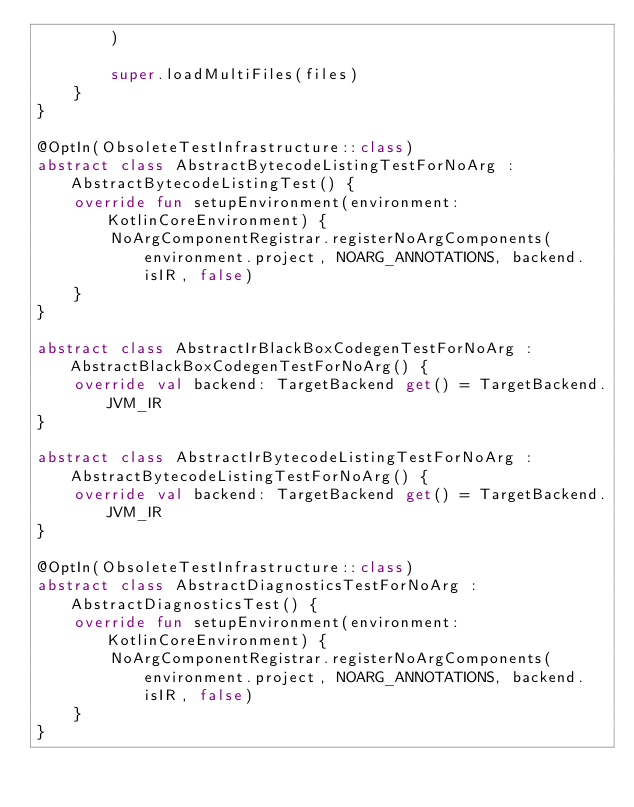<code> <loc_0><loc_0><loc_500><loc_500><_Kotlin_>        )

        super.loadMultiFiles(files)
    }
}

@OptIn(ObsoleteTestInfrastructure::class)
abstract class AbstractBytecodeListingTestForNoArg : AbstractBytecodeListingTest() {
    override fun setupEnvironment(environment: KotlinCoreEnvironment) {
        NoArgComponentRegistrar.registerNoArgComponents(environment.project, NOARG_ANNOTATIONS, backend.isIR, false)
    }
}

abstract class AbstractIrBlackBoxCodegenTestForNoArg : AbstractBlackBoxCodegenTestForNoArg() {
    override val backend: TargetBackend get() = TargetBackend.JVM_IR
}

abstract class AbstractIrBytecodeListingTestForNoArg : AbstractBytecodeListingTestForNoArg() {
    override val backend: TargetBackend get() = TargetBackend.JVM_IR
}

@OptIn(ObsoleteTestInfrastructure::class)
abstract class AbstractDiagnosticsTestForNoArg : AbstractDiagnosticsTest() {
    override fun setupEnvironment(environment: KotlinCoreEnvironment) {
        NoArgComponentRegistrar.registerNoArgComponents(environment.project, NOARG_ANNOTATIONS, backend.isIR, false)
    }
}
</code> 